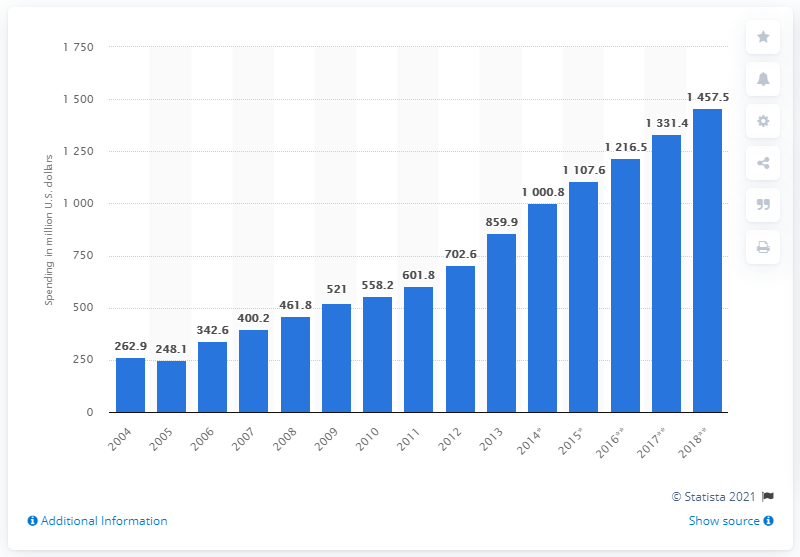What does the bar chart reveal about the trend in ad spending in Vietnam from 2004 to 2018? The bar chart illustrates a consistent upward trend in advertising expenditure in Vietnam from 2004, starting at 262.9 million US dollars, to 2018, reaching a spending of 1,457.5 million US dollars. The increase reflects Vietnam's growing market and potential for advertisers. 